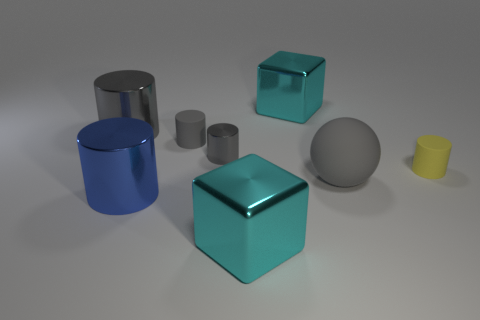Subtract all gray cylinders. How many were subtracted if there are1gray cylinders left? 2 Subtract all cyan cubes. How many gray cylinders are left? 3 Subtract 2 cylinders. How many cylinders are left? 3 Subtract all blue cylinders. How many cylinders are left? 4 Subtract all blue cylinders. How many cylinders are left? 4 Add 1 cyan metallic cubes. How many objects exist? 9 Subtract all blue cylinders. Subtract all red balls. How many cylinders are left? 4 Subtract all blocks. How many objects are left? 6 Subtract all tiny rubber cylinders. Subtract all tiny gray rubber cylinders. How many objects are left? 5 Add 5 large gray balls. How many large gray balls are left? 6 